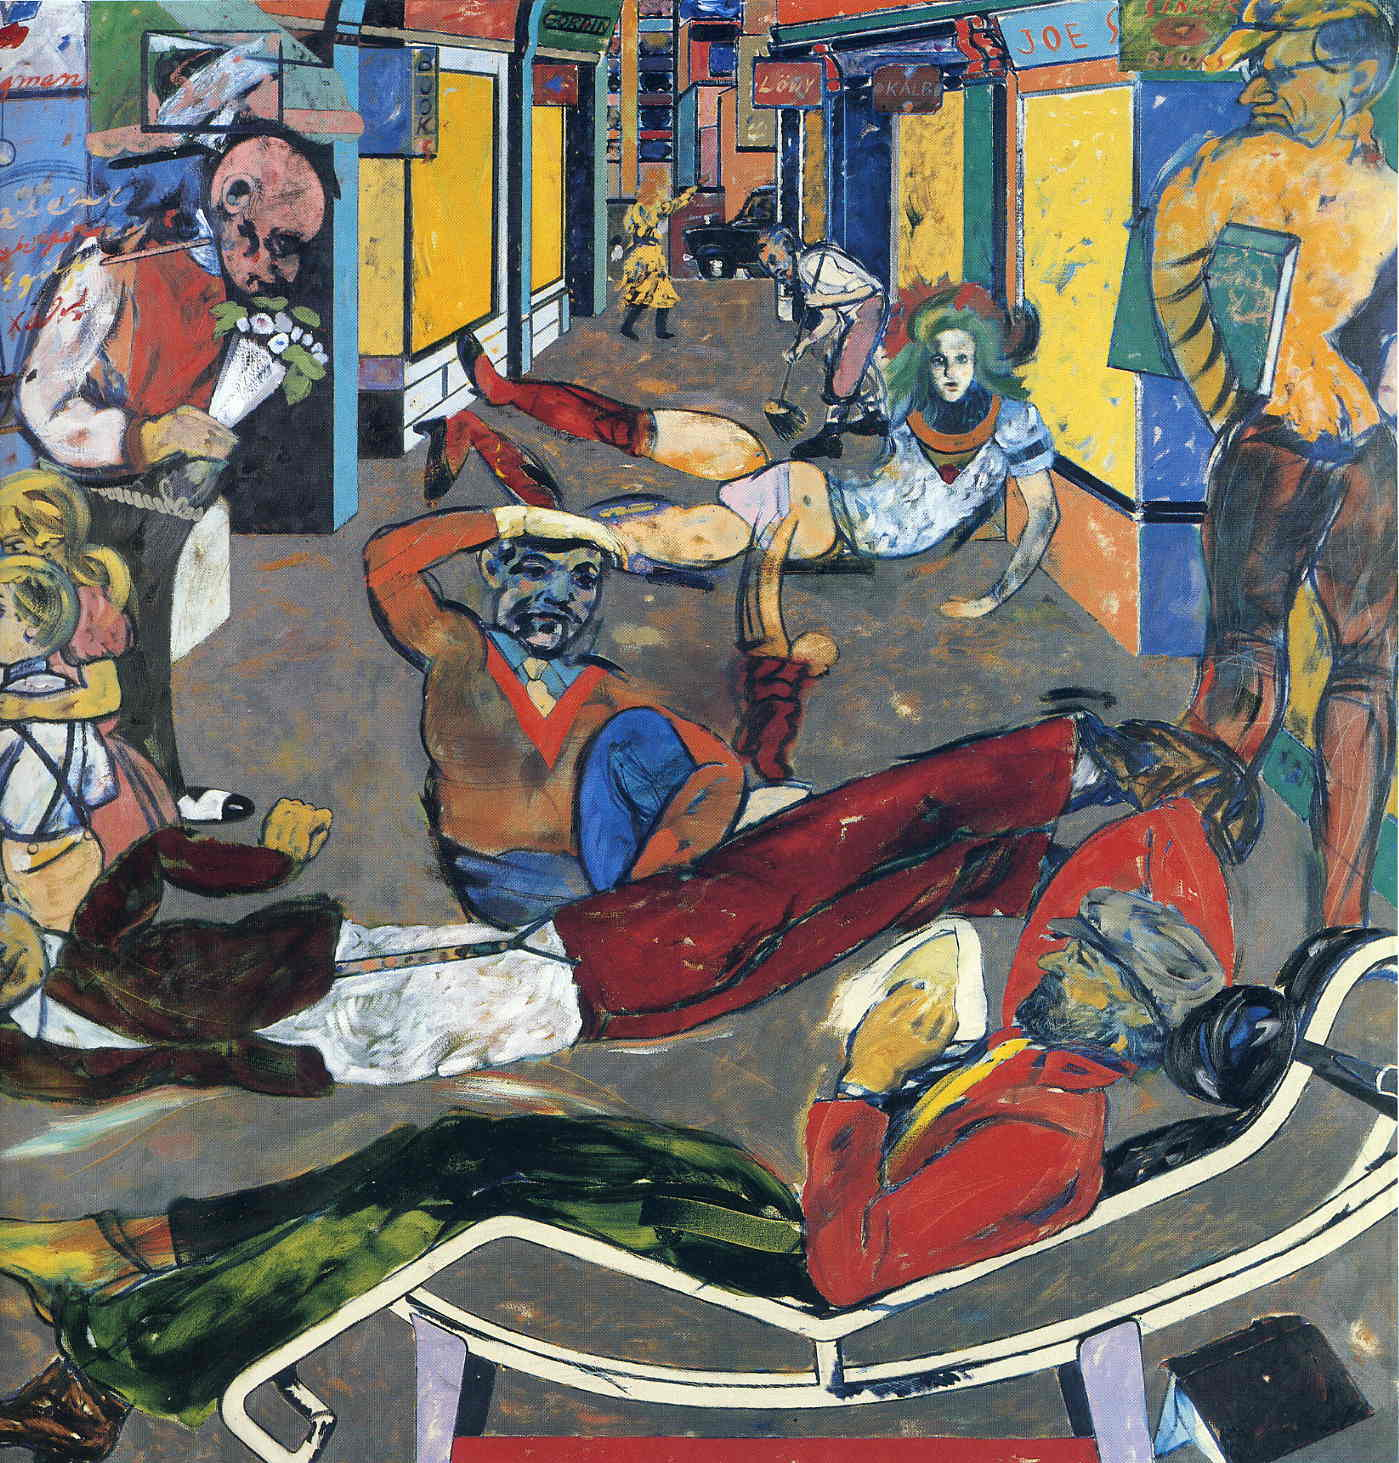What's going on in the street? The street depicted in the image is teeming with activity. Several figures are engaged in disparate activities; one person reads a newspaper while reclining, others dance or converse, and musicians passionately play their instruments. The exaggerated and abstract representation of the figures adds to the sense of frenetic energy and movement in the scene. Can you tell a story about the people in this scene? In a vibrant and bustling part of the city, these characters converge, each bringing their unique energy and story. The man lounging and reading the newspaper might be a local poet, absorbing the vibrant surroundings for his next work. The musicians could be street performers, their melodies intertwining with the city's heartbeat, while the dancers express their joy and freedom in their movements. Others, engaged in conversation or solitary reflection, contribute to the rich tapestry of urban life, each person a thread in the collective story of this lively street. What hidden details can you spot in the background? In the background, various buildings and shop signs can be observed, each contributing to the urban feel of the scene. The signs, with their bold lettering and contrasting colors, hint at a commercial district. A small figure appears to be walking further down the street, giving a sense of depth and perspective. These details, though subtle, add to the richness of the narrative, suggesting a thriving community existing within the broader scope of the city. If this scene were a snapshot in time, what might happen next? If this scene were a snapshot in time, the next moments might reveal even more interaction and movement. The street performers could attract a crowd, their music inspiring a wave of spontaneous dancing. The man reading might put down his newspaper to join the conversation with others. New characters could enter the scene, each bringing their own stories and adding to the dynamic fluidity of urban life. The background might reveal bustling shops opening for business or more pedestrians filling the streets, amplifying the sense of an ever-changing, living city. 